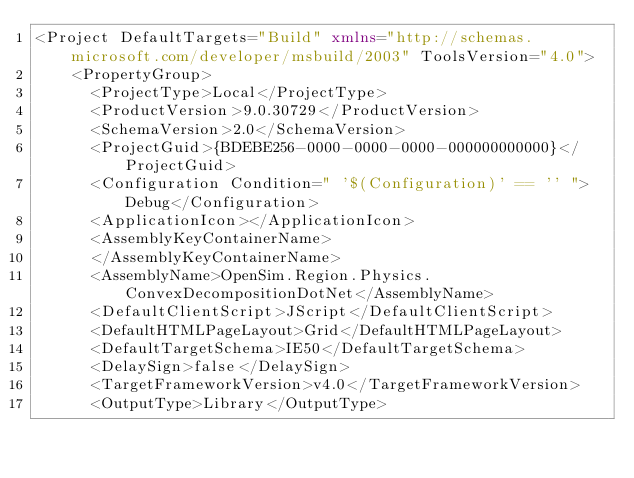<code> <loc_0><loc_0><loc_500><loc_500><_XML_><Project DefaultTargets="Build" xmlns="http://schemas.microsoft.com/developer/msbuild/2003" ToolsVersion="4.0">
	<PropertyGroup>
	  <ProjectType>Local</ProjectType>
	  <ProductVersion>9.0.30729</ProductVersion>
	  <SchemaVersion>2.0</SchemaVersion>
	  <ProjectGuid>{BDEBE256-0000-0000-0000-000000000000}</ProjectGuid>
	  <Configuration Condition=" '$(Configuration)' == '' ">Debug</Configuration>
	  <ApplicationIcon></ApplicationIcon>
	  <AssemblyKeyContainerName>
	  </AssemblyKeyContainerName>
	  <AssemblyName>OpenSim.Region.Physics.ConvexDecompositionDotNet</AssemblyName>
	  <DefaultClientScript>JScript</DefaultClientScript>
	  <DefaultHTMLPageLayout>Grid</DefaultHTMLPageLayout>
	  <DefaultTargetSchema>IE50</DefaultTargetSchema>
	  <DelaySign>false</DelaySign>
	  <TargetFrameworkVersion>v4.0</TargetFrameworkVersion>
	  <OutputType>Library</OutputType></code> 